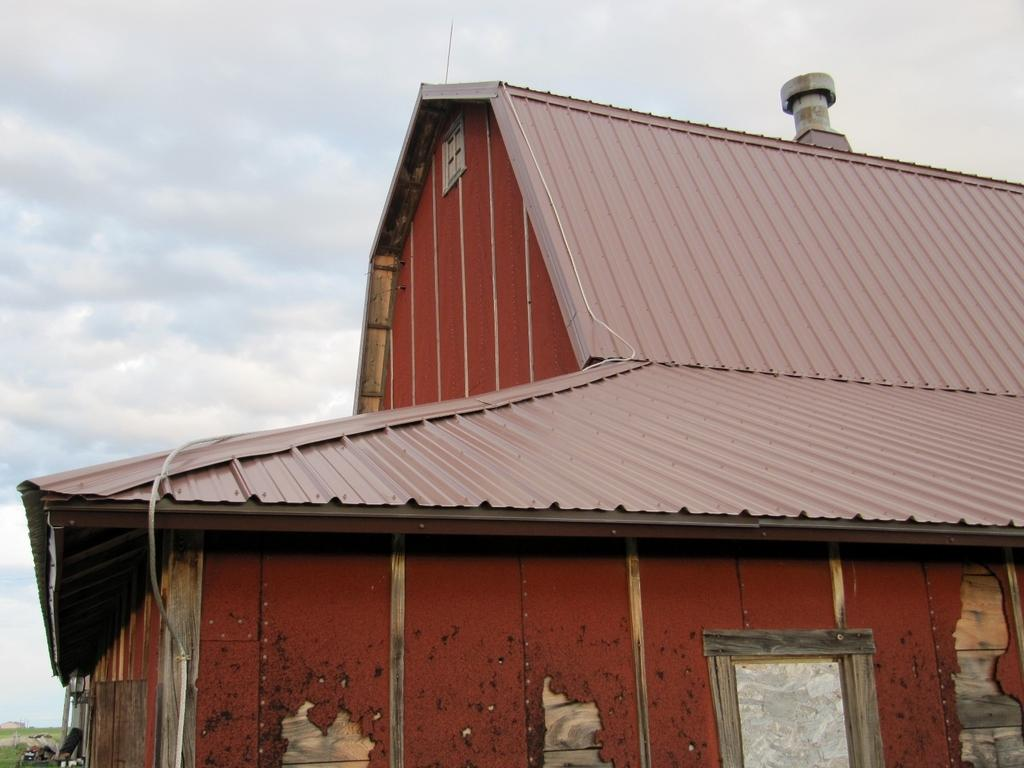What type of structure is present in the image? There is a building in the image. What other objects can be seen in the image? There is a tire and some unspecified objects in the image. What type of terrain is visible in the image? There is grass in the image. What is visible at the top of the image? The sky is visible at the top of the image. What type of jam is being used to repair the carriage in the image? There is no carriage or jam present in the image. 